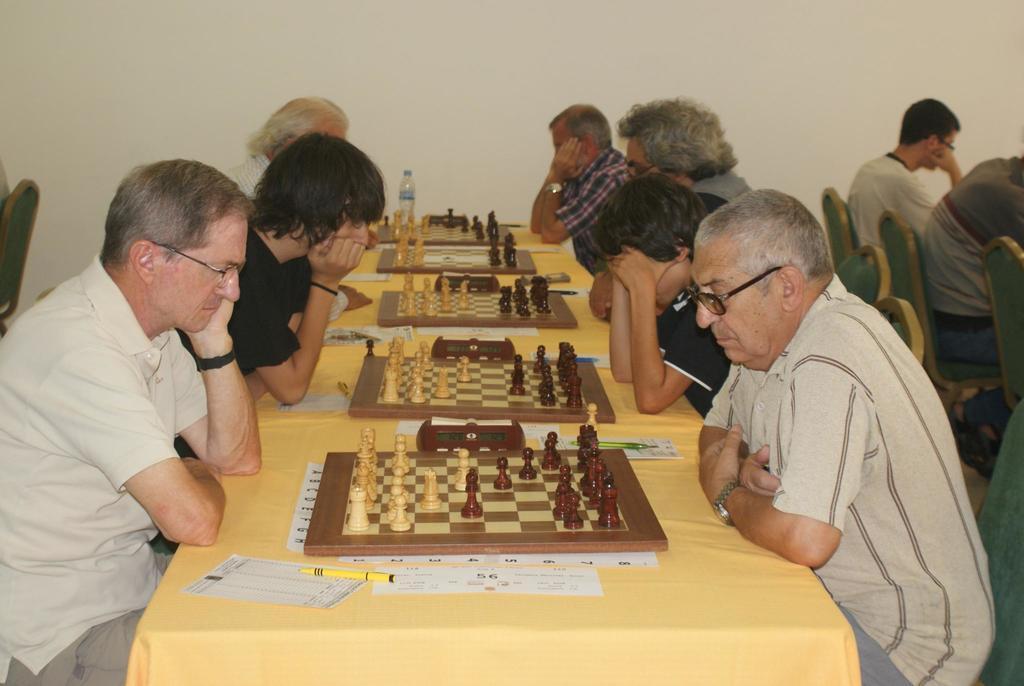Please provide a concise description of this image. In this image there are group of people sitting on the chair. On the table there is chess board,paper and a pen. 